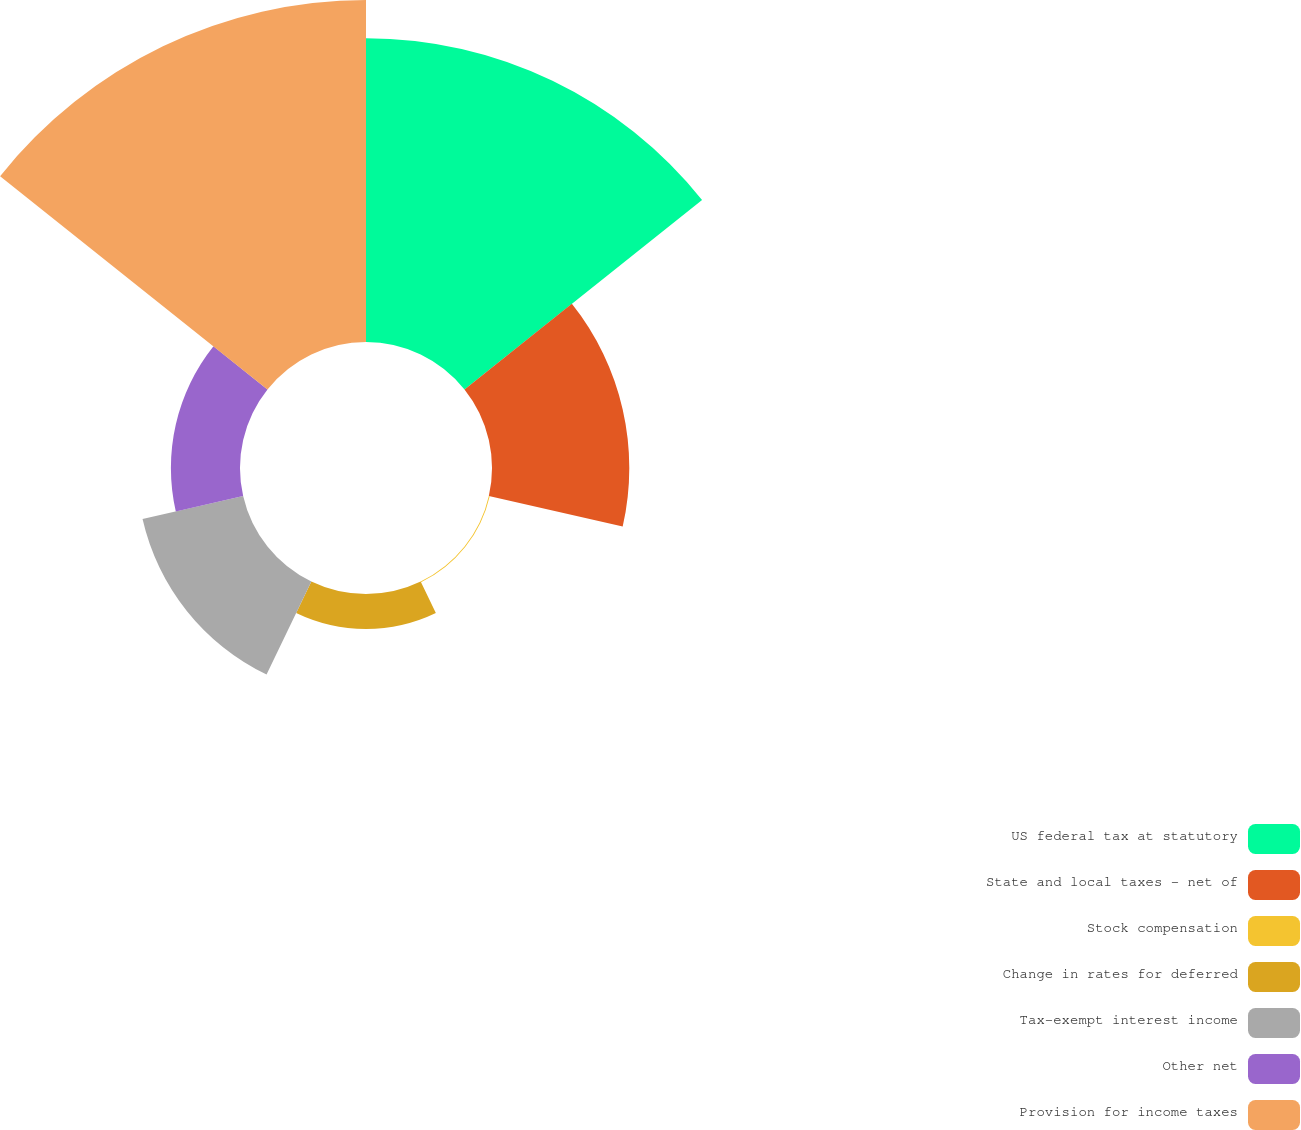Convert chart. <chart><loc_0><loc_0><loc_500><loc_500><pie_chart><fcel>US federal tax at statutory<fcel>State and local taxes - net of<fcel>Stock compensation<fcel>Change in rates for deferred<fcel>Tax-exempt interest income<fcel>Other net<fcel>Provision for income taxes<nl><fcel>30.65%<fcel>13.85%<fcel>0.09%<fcel>3.53%<fcel>10.41%<fcel>6.97%<fcel>34.5%<nl></chart> 